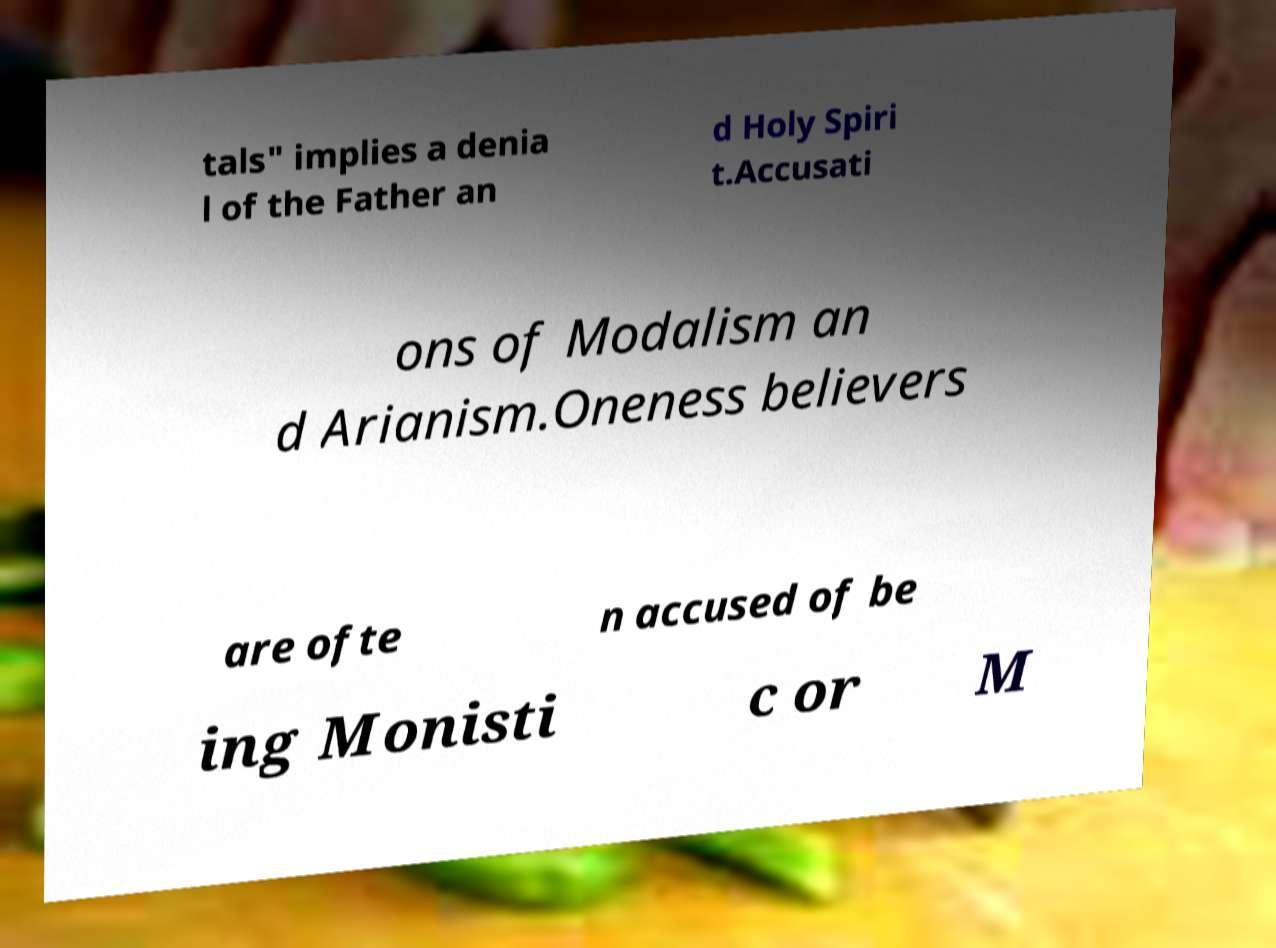What messages or text are displayed in this image? I need them in a readable, typed format. tals" implies a denia l of the Father an d Holy Spiri t.Accusati ons of Modalism an d Arianism.Oneness believers are ofte n accused of be ing Monisti c or M 